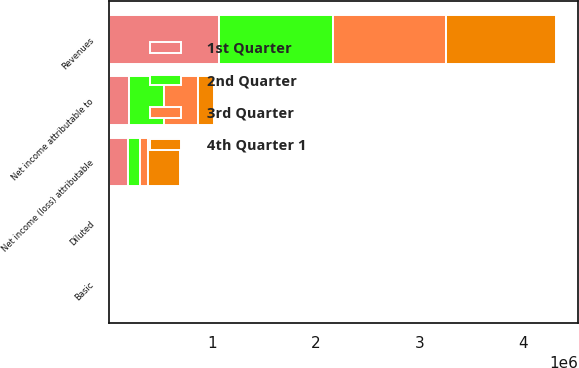Convert chart to OTSL. <chart><loc_0><loc_0><loc_500><loc_500><stacked_bar_chart><ecel><fcel>Revenues<fcel>Net income (loss) attributable<fcel>Basic<fcel>Diluted<fcel>Net income attributable to<nl><fcel>4th Quarter 1<fcel>1.0623e+06<fcel>312639<fcel>0.86<fcel>0.86<fcel>148969<nl><fcel>1st Quarter<fcel>1.0586e+06<fcel>188429<fcel>0.51<fcel>0.51<fcel>195474<nl><fcel>3rd Quarter<fcel>1.09148e+06<fcel>74043<fcel>0.2<fcel>0.2<fcel>334910<nl><fcel>2nd Quarter<fcel>1.10426e+06<fcel>111523<fcel>0.31<fcel>0.31<fcel>333044<nl></chart> 